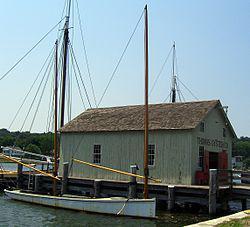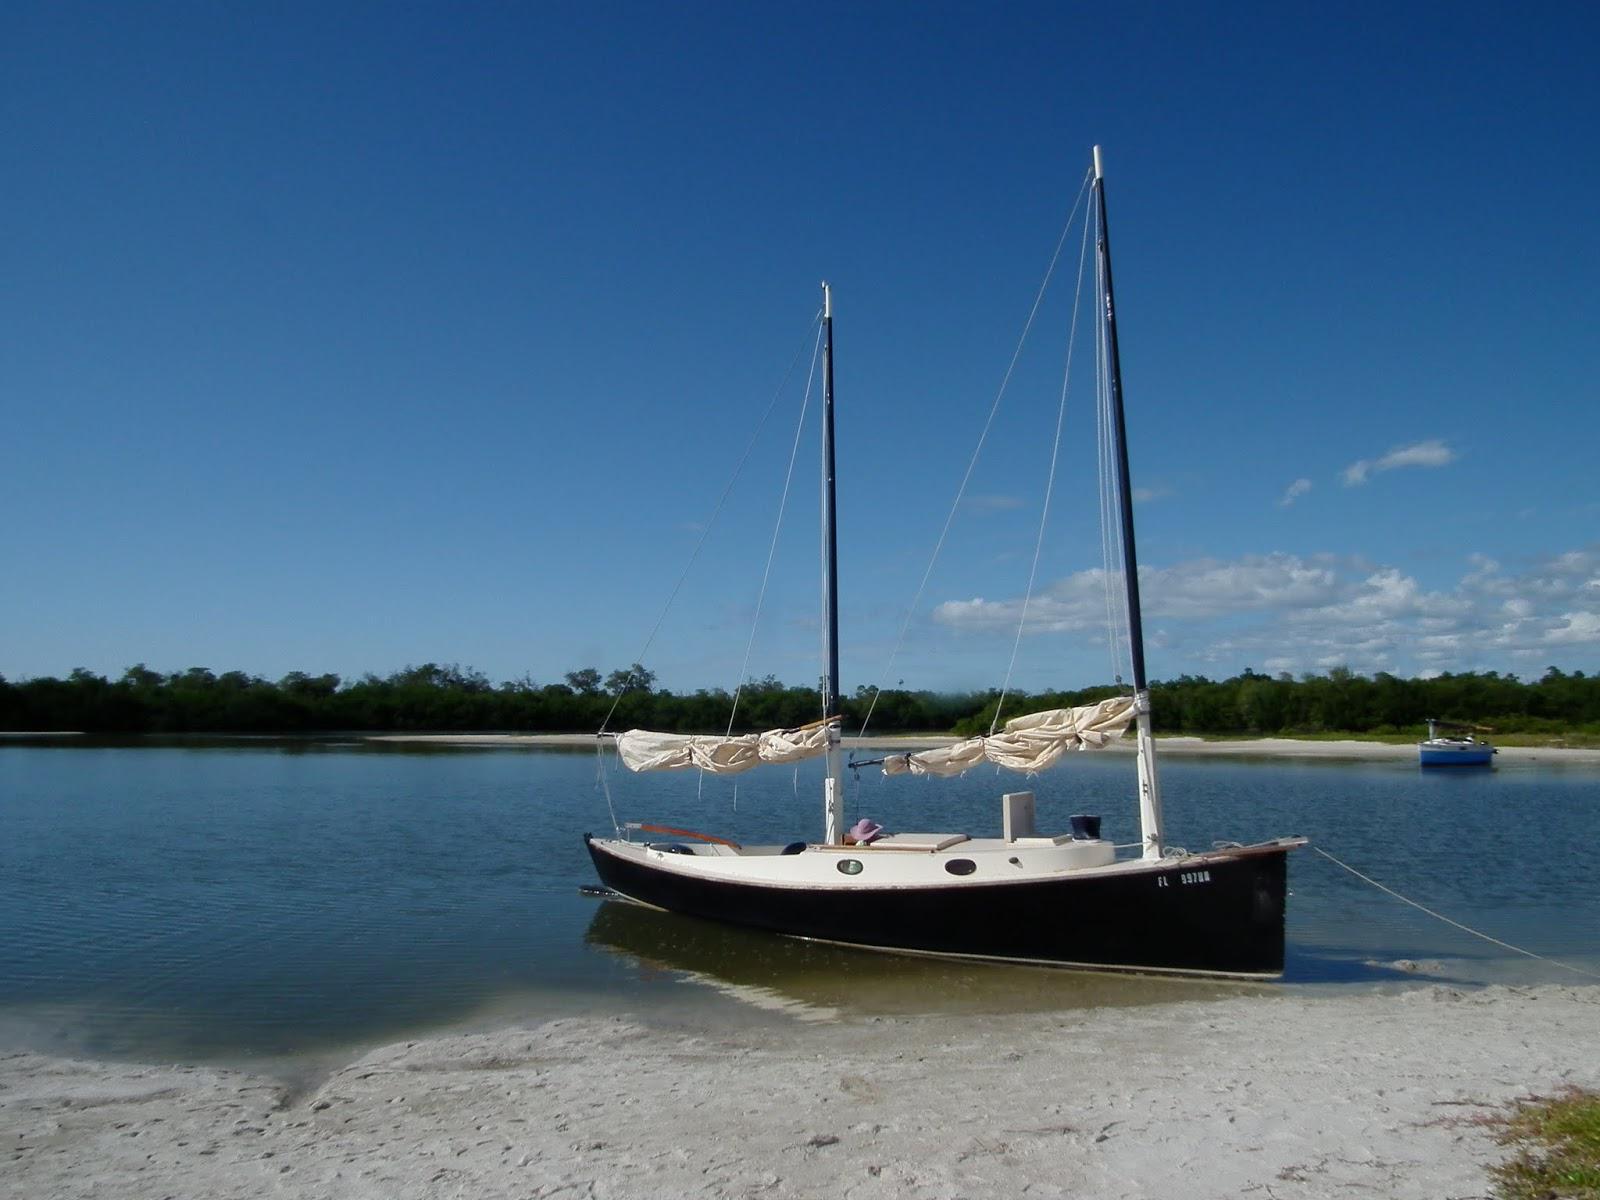The first image is the image on the left, the second image is the image on the right. Analyze the images presented: Is the assertion "There is at least one human onboard each boat." valid? Answer yes or no. No. The first image is the image on the left, the second image is the image on the right. For the images displayed, is the sentence "At least one boat is docked near a building in one of the images." factually correct? Answer yes or no. Yes. 